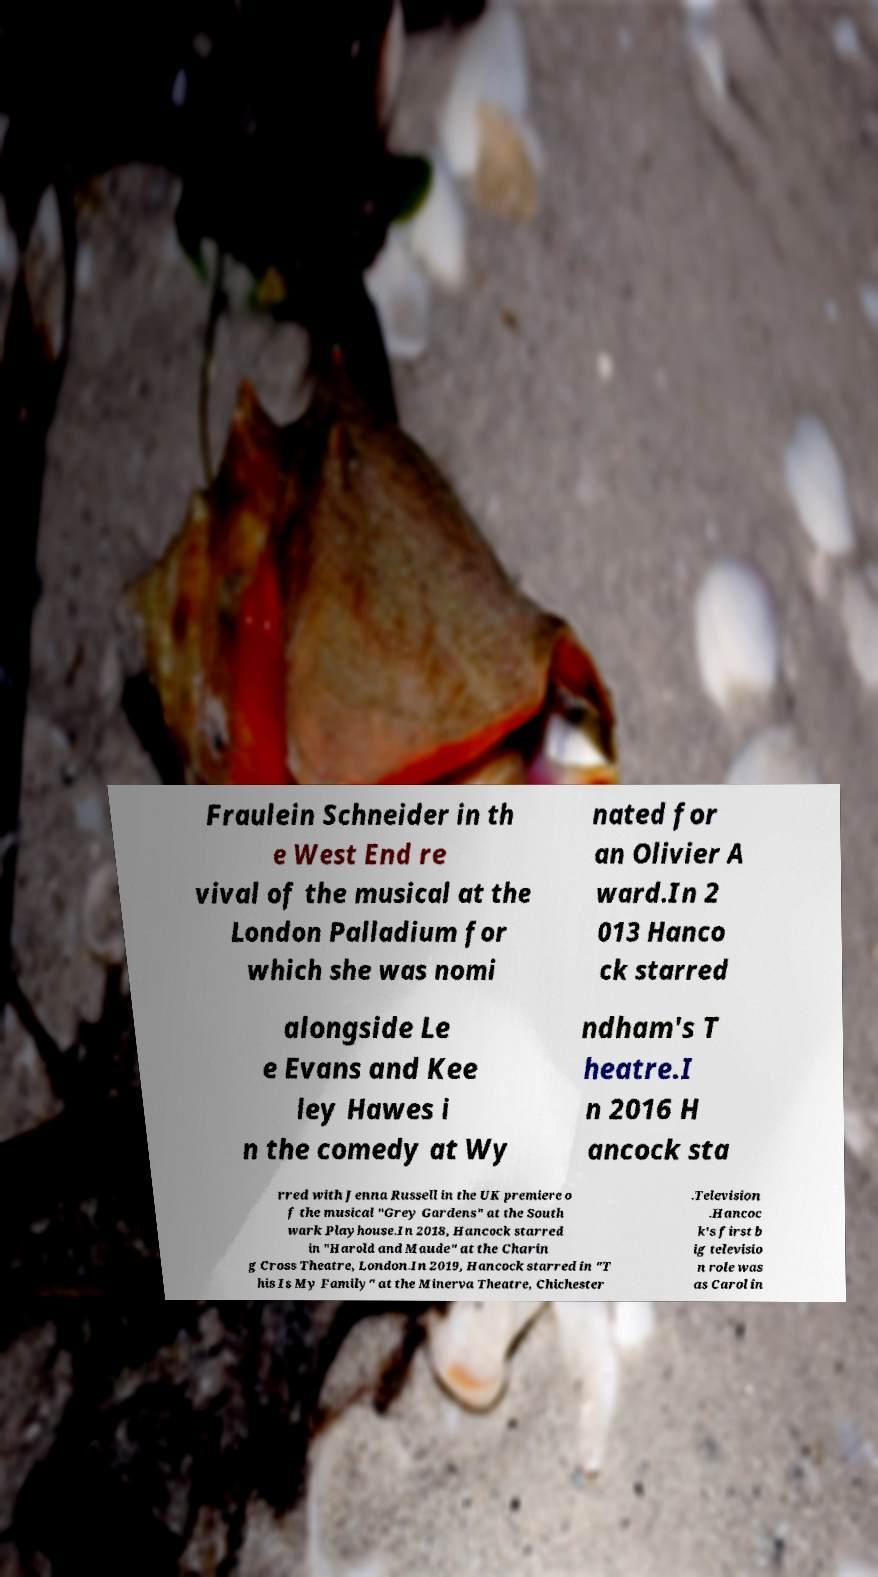Could you extract and type out the text from this image? Fraulein Schneider in th e West End re vival of the musical at the London Palladium for which she was nomi nated for an Olivier A ward.In 2 013 Hanco ck starred alongside Le e Evans and Kee ley Hawes i n the comedy at Wy ndham's T heatre.I n 2016 H ancock sta rred with Jenna Russell in the UK premiere o f the musical "Grey Gardens" at the South wark Playhouse.In 2018, Hancock starred in "Harold and Maude" at the Charin g Cross Theatre, London.In 2019, Hancock starred in "T his Is My Family" at the Minerva Theatre, Chichester .Television .Hancoc k's first b ig televisio n role was as Carol in 